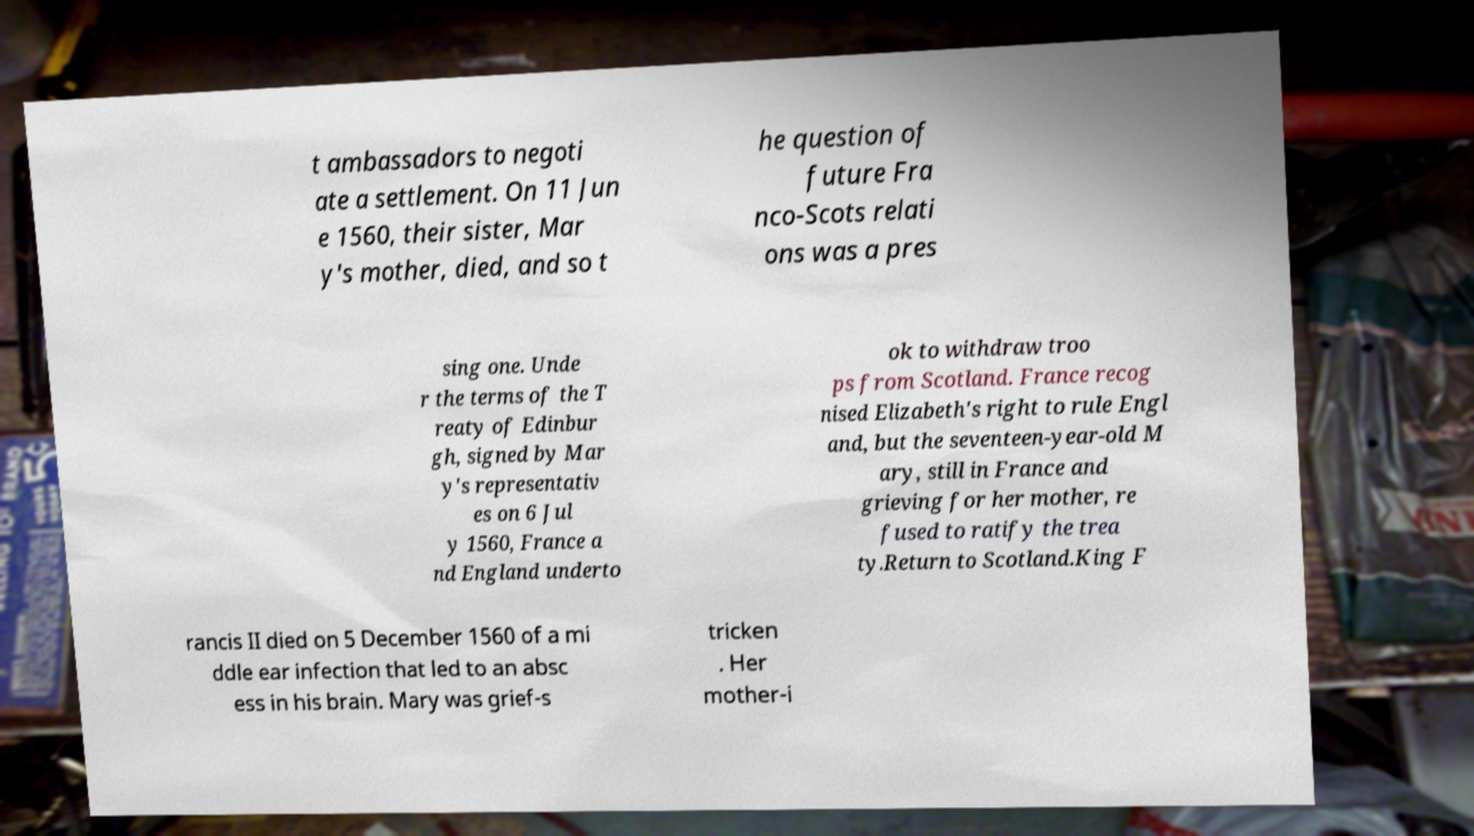I need the written content from this picture converted into text. Can you do that? t ambassadors to negoti ate a settlement. On 11 Jun e 1560, their sister, Mar y's mother, died, and so t he question of future Fra nco-Scots relati ons was a pres sing one. Unde r the terms of the T reaty of Edinbur gh, signed by Mar y's representativ es on 6 Jul y 1560, France a nd England underto ok to withdraw troo ps from Scotland. France recog nised Elizabeth's right to rule Engl and, but the seventeen-year-old M ary, still in France and grieving for her mother, re fused to ratify the trea ty.Return to Scotland.King F rancis II died on 5 December 1560 of a mi ddle ear infection that led to an absc ess in his brain. Mary was grief-s tricken . Her mother-i 